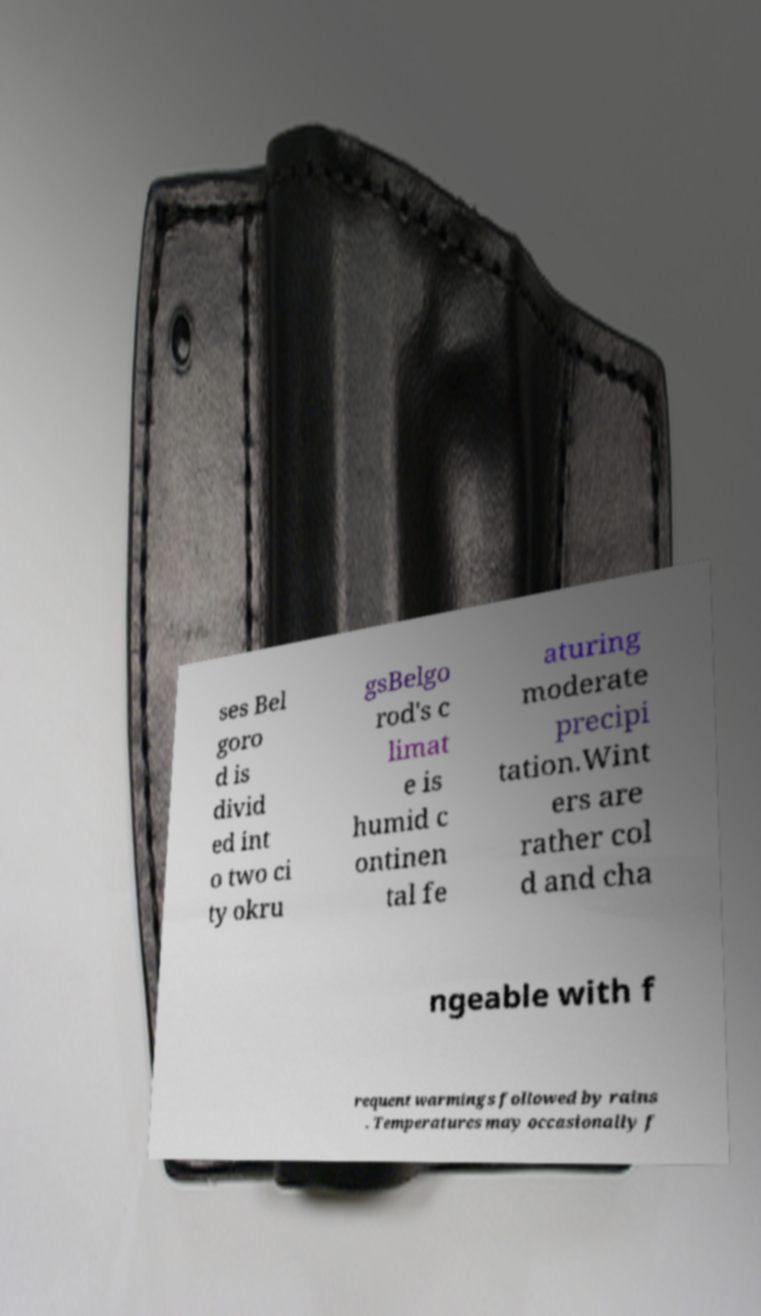I need the written content from this picture converted into text. Can you do that? ses Bel goro d is divid ed int o two ci ty okru gsBelgo rod's c limat e is humid c ontinen tal fe aturing moderate precipi tation.Wint ers are rather col d and cha ngeable with f requent warmings followed by rains . Temperatures may occasionally f 